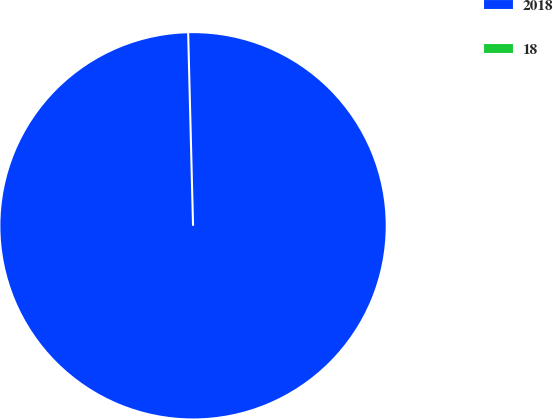Convert chart. <chart><loc_0><loc_0><loc_500><loc_500><pie_chart><fcel>2018<fcel>18<nl><fcel>100.0%<fcel>0.0%<nl></chart> 